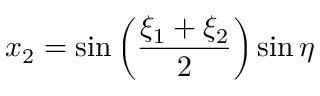Convert formula to latex. <formula><loc_0><loc_0><loc_500><loc_500>x _ { 2 } = \sin \left ( { \frac { \xi _ { 1 } + \xi _ { 2 } } { 2 } } \right ) \sin \eta</formula> 